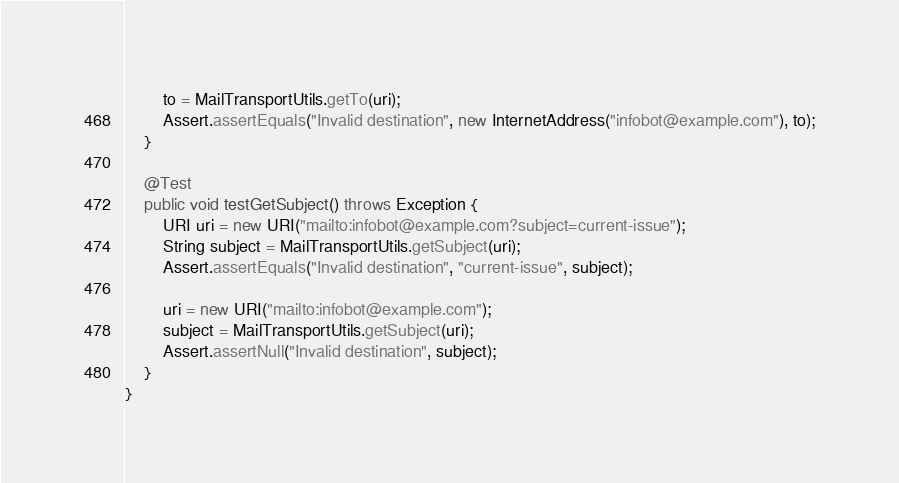<code> <loc_0><loc_0><loc_500><loc_500><_Java_>        to = MailTransportUtils.getTo(uri);
        Assert.assertEquals("Invalid destination", new InternetAddress("infobot@example.com"), to);
    }

    @Test
    public void testGetSubject() throws Exception {
        URI uri = new URI("mailto:infobot@example.com?subject=current-issue");
        String subject = MailTransportUtils.getSubject(uri);
        Assert.assertEquals("Invalid destination", "current-issue", subject);

        uri = new URI("mailto:infobot@example.com");
        subject = MailTransportUtils.getSubject(uri);
        Assert.assertNull("Invalid destination", subject);
    }
}</code> 